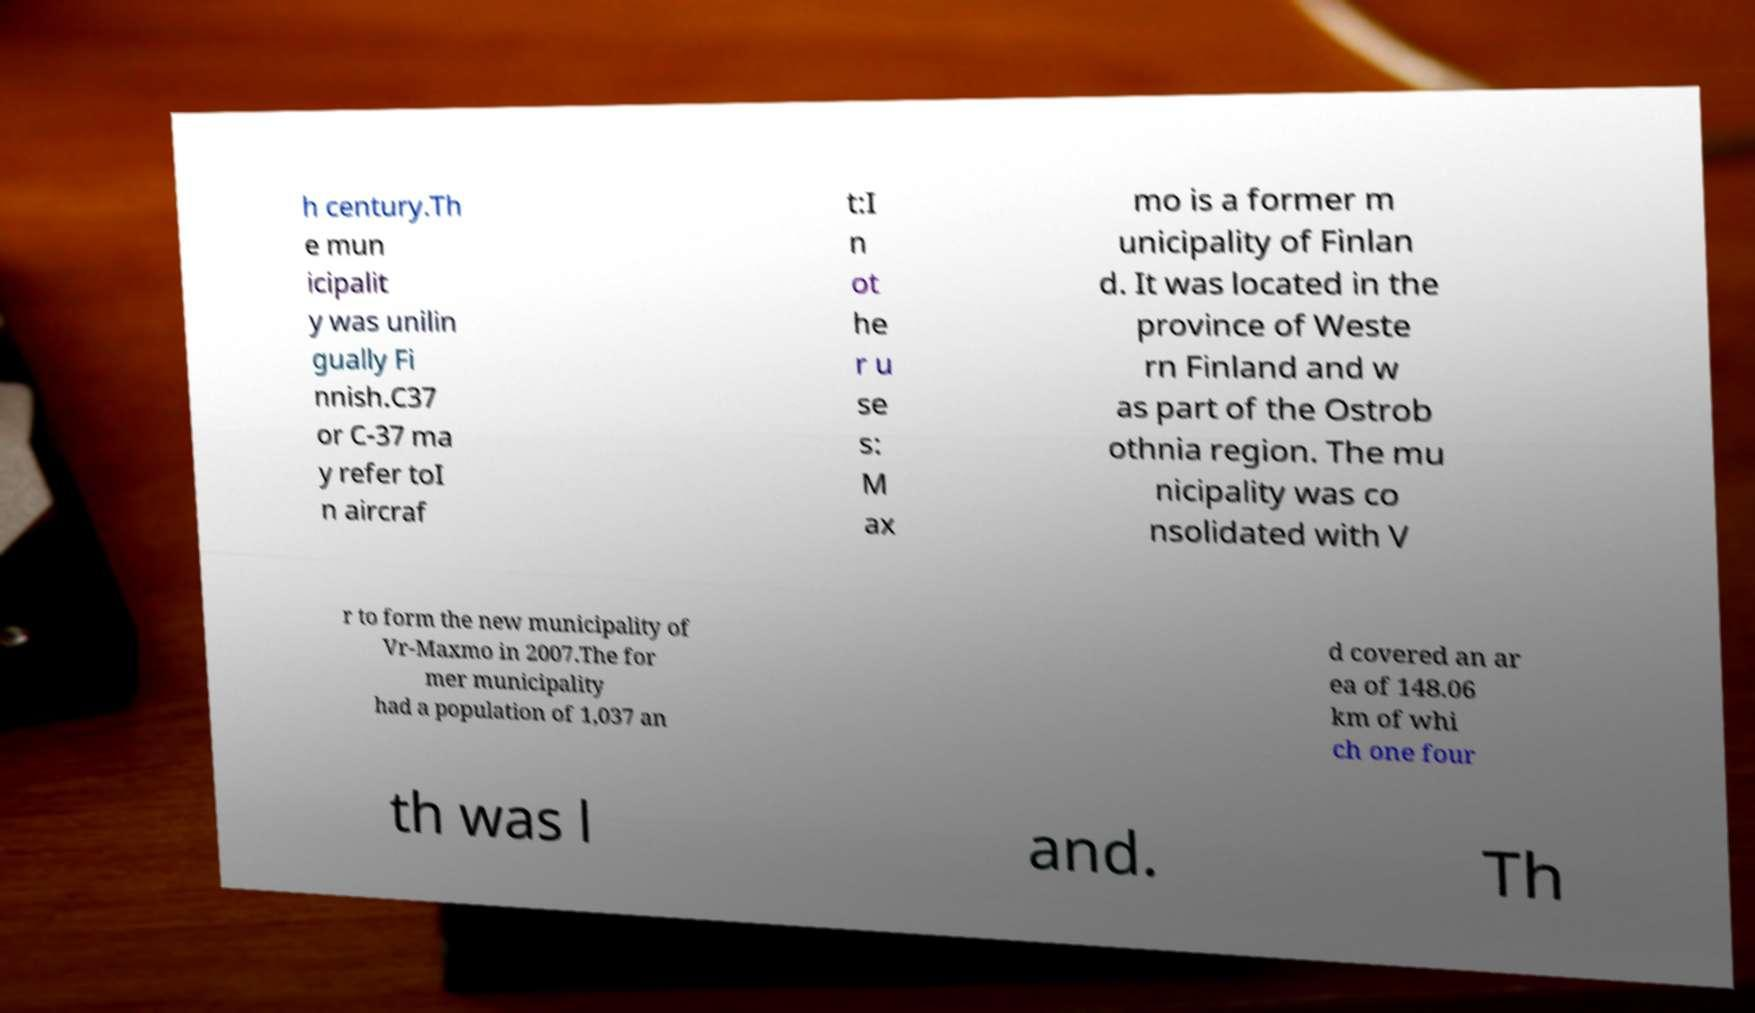Can you accurately transcribe the text from the provided image for me? h century.Th e mun icipalit y was unilin gually Fi nnish.C37 or C-37 ma y refer toI n aircraf t:I n ot he r u se s: M ax mo is a former m unicipality of Finlan d. It was located in the province of Weste rn Finland and w as part of the Ostrob othnia region. The mu nicipality was co nsolidated with V r to form the new municipality of Vr-Maxmo in 2007.The for mer municipality had a population of 1,037 an d covered an ar ea of 148.06 km of whi ch one four th was l and. Th 